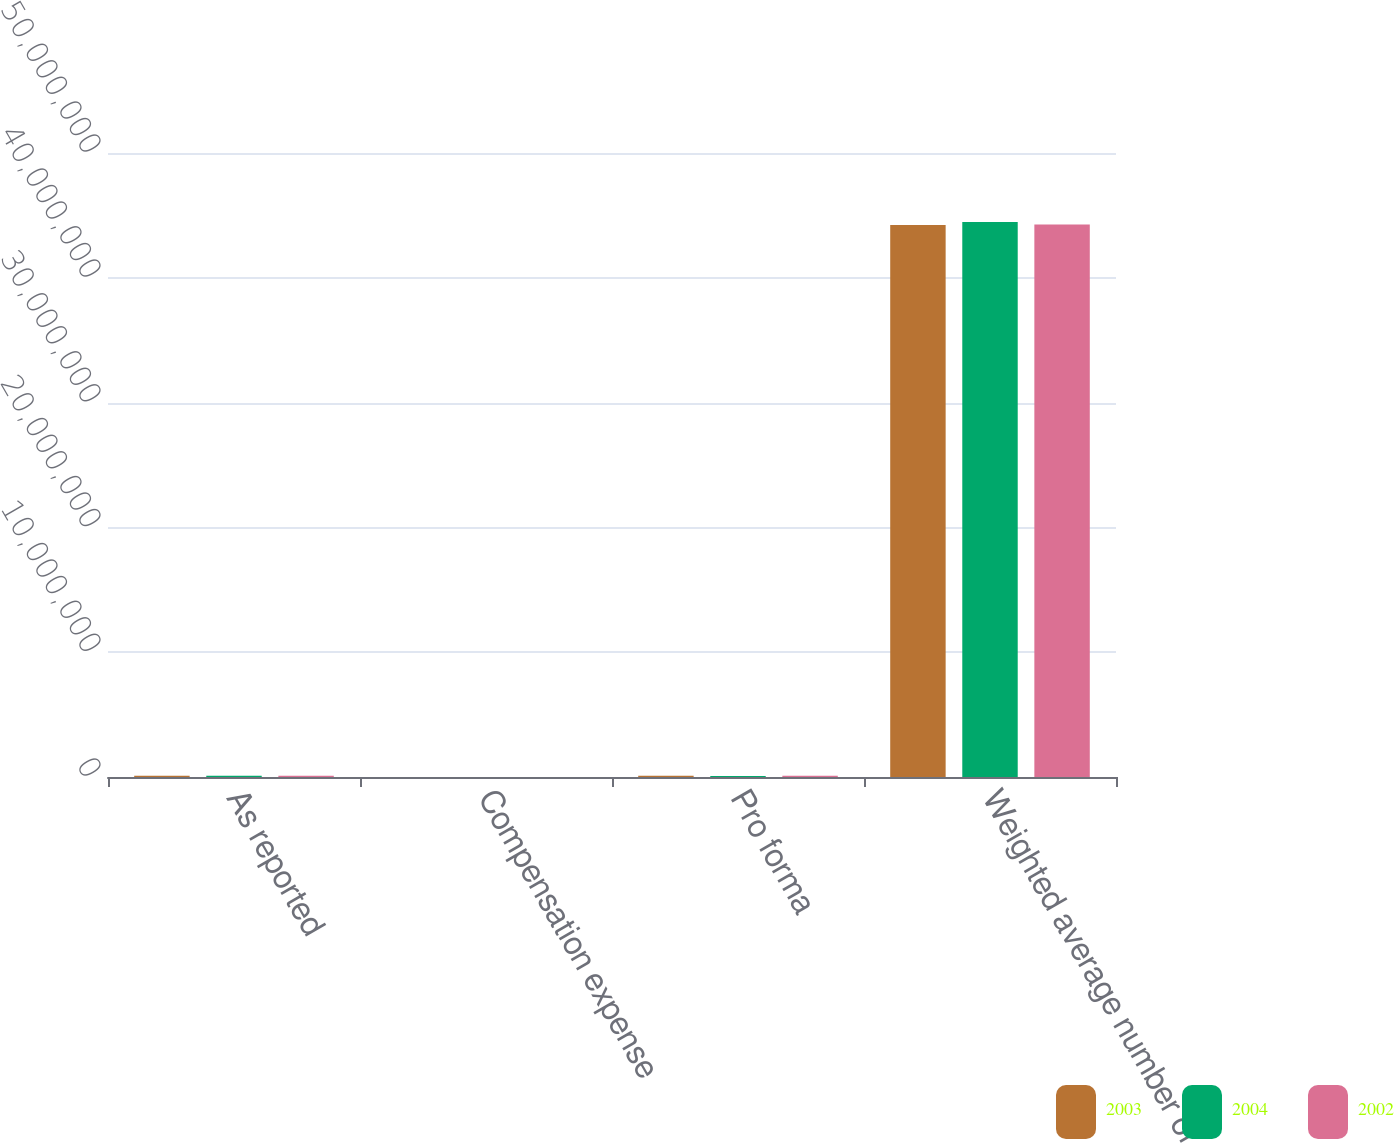Convert chart. <chart><loc_0><loc_0><loc_500><loc_500><stacked_bar_chart><ecel><fcel>As reported<fcel>Compensation expense<fcel>Pro forma<fcel>Weighted average number of<nl><fcel>2003<fcel>107957<fcel>7290<fcel>100667<fcel>4.42372e+07<nl><fcel>2004<fcel>95838<fcel>6748<fcel>89090<fcel>4.44739e+07<nl><fcel>2002<fcel>100421<fcel>5809<fcel>94612<fcel>4.42806e+07<nl></chart> 